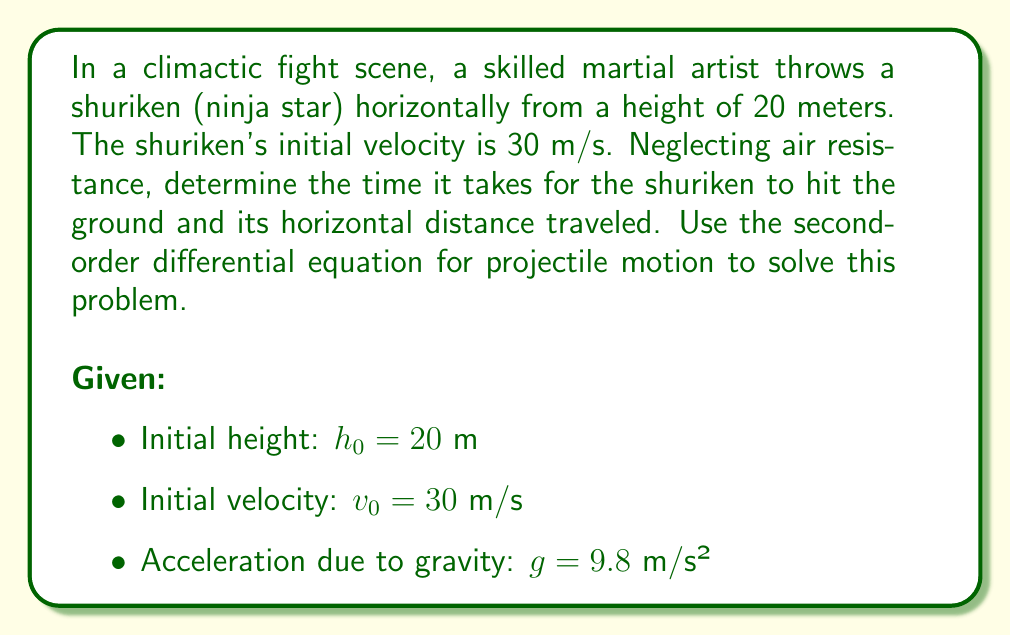Can you solve this math problem? Let's approach this problem step-by-step using second-order differential equations:

1) For vertical motion:
   The second-order differential equation for vertical motion is:
   
   $$\frac{d^2y}{dt^2} = -g$$

   Where $y$ is the vertical position and $t$ is time.

2) Integrating once:
   
   $$\frac{dy}{dt} = -gt + C_1$$

   Initial condition: At $t=0$, $\frac{dy}{dt} = 0$ (vertical velocity is zero initially)
   Therefore, $C_1 = 0$

3) Integrating again:
   
   $$y = -\frac{1}{2}gt^2 + C_2$$

   Initial condition: At $t=0$, $y = h_0 = 20$
   Therefore, $C_2 = 20$

   So, the equation for vertical position is:
   
   $$y = -\frac{1}{2}gt^2 + 20$$

4) To find the time when the shuriken hits the ground, set $y = 0$:
   
   $$0 = -\frac{1}{2}(9.8)t^2 + 20$$
   $$4.9t^2 = 20$$
   $$t^2 = \frac{20}{4.9} \approx 4.0816$$
   $$t \approx 2.02 \text{ seconds}$$

5) For horizontal motion:
   The second-order differential equation is:
   
   $$\frac{d^2x}{dt^2} = 0$$

   Because there's no horizontal acceleration.

6) Integrating twice:
   
   $$\frac{dx}{dt} = v_0 = 30$$
   $$x = 30t + C$$

   At $t=0$, $x=0$, so $C=0$

7) The horizontal distance traveled is:
   
   $$x = 30 * 2.02 \approx 60.6 \text{ meters}$$

Therefore, the shuriken will hit the ground after approximately 2.02 seconds and travel about 60.6 meters horizontally.
Answer: Time to hit the ground: $t \approx 2.02$ seconds
Horizontal distance traveled: $x \approx 60.6$ meters 